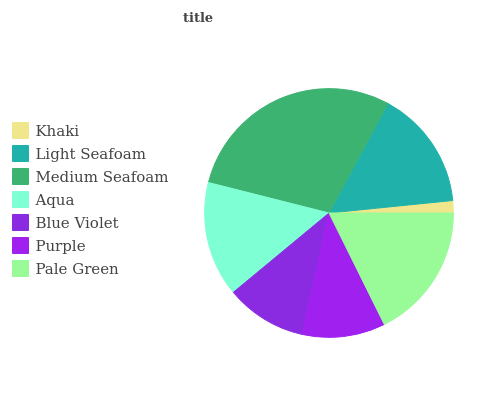Is Khaki the minimum?
Answer yes or no. Yes. Is Medium Seafoam the maximum?
Answer yes or no. Yes. Is Light Seafoam the minimum?
Answer yes or no. No. Is Light Seafoam the maximum?
Answer yes or no. No. Is Light Seafoam greater than Khaki?
Answer yes or no. Yes. Is Khaki less than Light Seafoam?
Answer yes or no. Yes. Is Khaki greater than Light Seafoam?
Answer yes or no. No. Is Light Seafoam less than Khaki?
Answer yes or no. No. Is Aqua the high median?
Answer yes or no. Yes. Is Aqua the low median?
Answer yes or no. Yes. Is Purple the high median?
Answer yes or no. No. Is Blue Violet the low median?
Answer yes or no. No. 